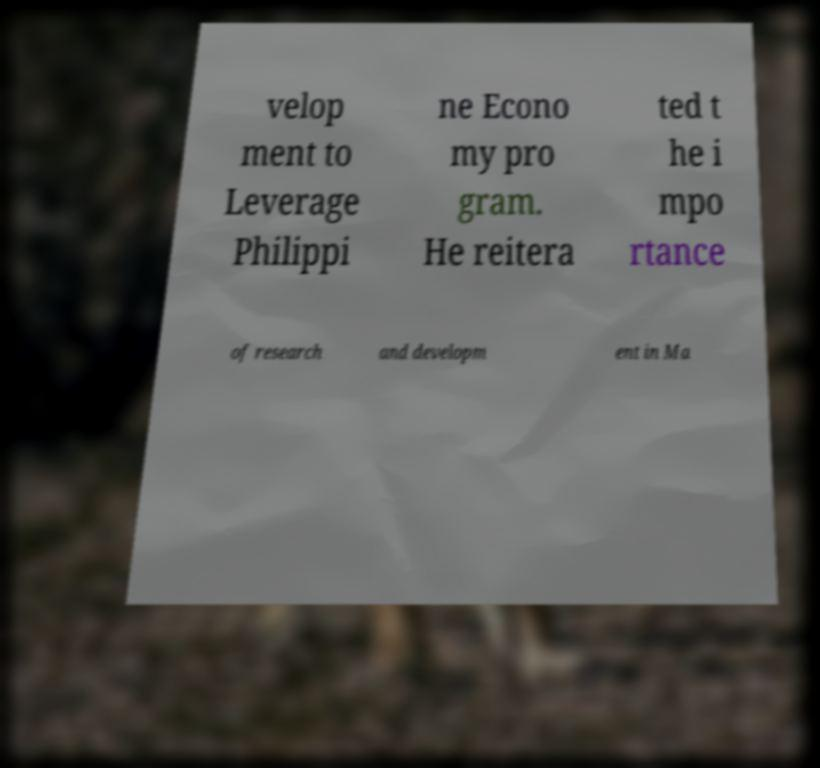I need the written content from this picture converted into text. Can you do that? velop ment to Leverage Philippi ne Econo my pro gram. He reitera ted t he i mpo rtance of research and developm ent in Ma 